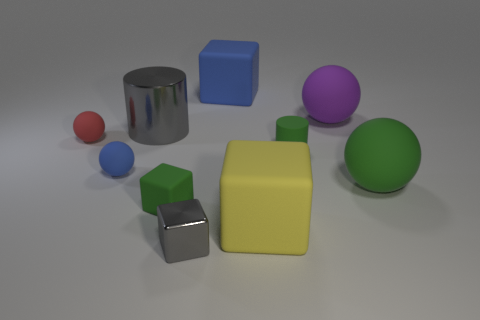Is there a metallic ball of the same color as the large cylinder?
Your response must be concise. No. How many rubber things are either tiny gray cubes or brown balls?
Your response must be concise. 0. There is a gray object that is behind the small cylinder; how many purple matte spheres are in front of it?
Offer a terse response. 0. What number of big cylinders have the same material as the tiny gray thing?
Offer a terse response. 1. How many tiny things are either red matte spheres or gray shiny cylinders?
Your response must be concise. 1. What shape is the small thing that is both behind the blue sphere and on the left side of the green matte cube?
Give a very brief answer. Sphere. Are the large purple ball and the yellow block made of the same material?
Make the answer very short. Yes. What is the color of the metal cylinder that is the same size as the purple matte sphere?
Your answer should be compact. Gray. What color is the rubber ball that is to the left of the small metal thing and in front of the red matte sphere?
Your answer should be very brief. Blue. There is a cube that is the same color as the small cylinder; what size is it?
Offer a terse response. Small. 